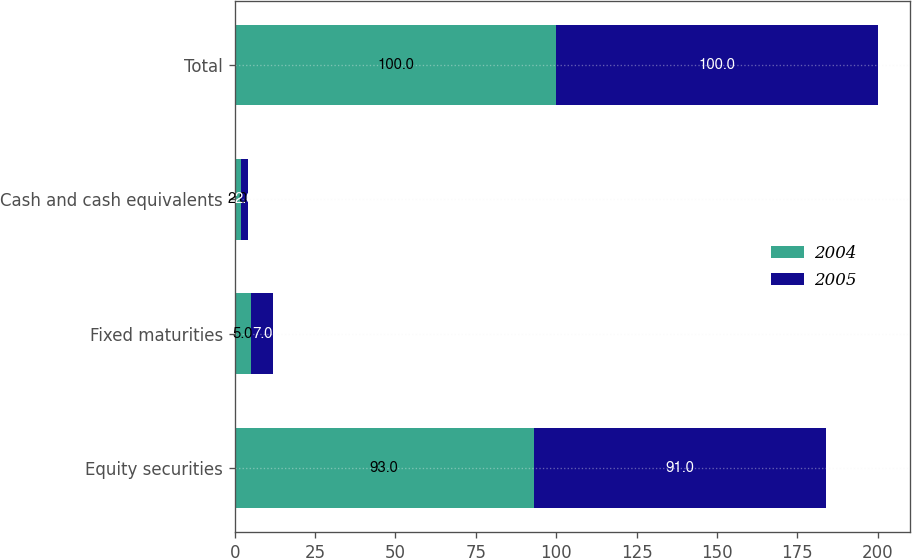<chart> <loc_0><loc_0><loc_500><loc_500><stacked_bar_chart><ecel><fcel>Equity securities<fcel>Fixed maturities<fcel>Cash and cash equivalents<fcel>Total<nl><fcel>2004<fcel>93<fcel>5<fcel>2<fcel>100<nl><fcel>2005<fcel>91<fcel>7<fcel>2<fcel>100<nl></chart> 